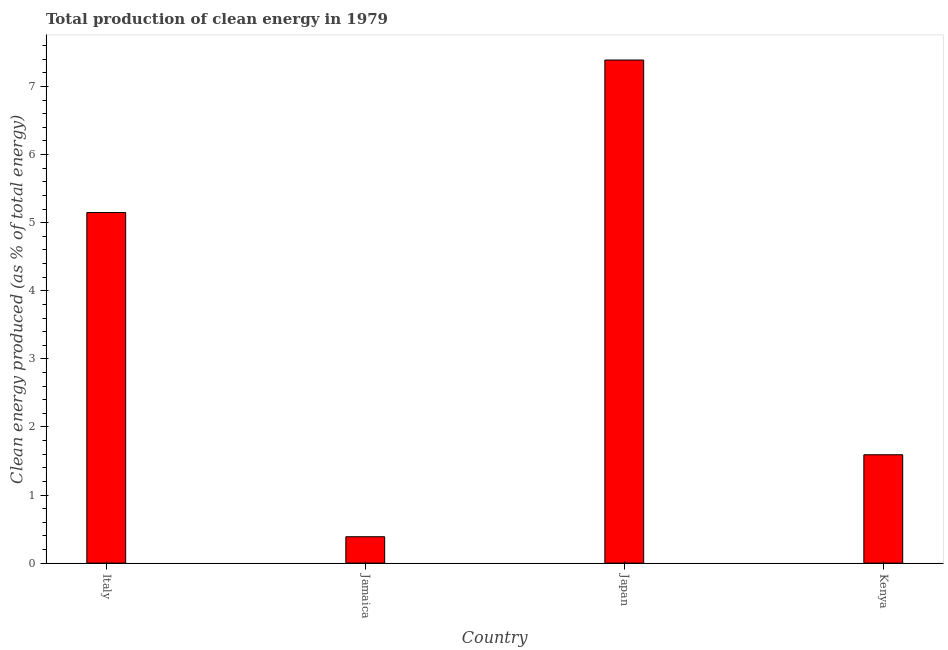Does the graph contain grids?
Make the answer very short. No. What is the title of the graph?
Make the answer very short. Total production of clean energy in 1979. What is the label or title of the X-axis?
Your response must be concise. Country. What is the label or title of the Y-axis?
Keep it short and to the point. Clean energy produced (as % of total energy). What is the production of clean energy in Japan?
Offer a very short reply. 7.39. Across all countries, what is the maximum production of clean energy?
Your response must be concise. 7.39. Across all countries, what is the minimum production of clean energy?
Offer a very short reply. 0.39. In which country was the production of clean energy maximum?
Your answer should be compact. Japan. In which country was the production of clean energy minimum?
Your answer should be compact. Jamaica. What is the sum of the production of clean energy?
Keep it short and to the point. 14.52. What is the difference between the production of clean energy in Italy and Jamaica?
Your response must be concise. 4.76. What is the average production of clean energy per country?
Provide a short and direct response. 3.63. What is the median production of clean energy?
Ensure brevity in your answer.  3.37. What is the ratio of the production of clean energy in Japan to that in Kenya?
Offer a very short reply. 4.64. Is the production of clean energy in Jamaica less than that in Japan?
Your answer should be compact. Yes. Is the difference between the production of clean energy in Italy and Kenya greater than the difference between any two countries?
Provide a succinct answer. No. What is the difference between the highest and the second highest production of clean energy?
Give a very brief answer. 2.24. In how many countries, is the production of clean energy greater than the average production of clean energy taken over all countries?
Your answer should be very brief. 2. Are all the bars in the graph horizontal?
Keep it short and to the point. No. How many countries are there in the graph?
Your answer should be compact. 4. Are the values on the major ticks of Y-axis written in scientific E-notation?
Keep it short and to the point. No. What is the Clean energy produced (as % of total energy) of Italy?
Give a very brief answer. 5.15. What is the Clean energy produced (as % of total energy) in Jamaica?
Your response must be concise. 0.39. What is the Clean energy produced (as % of total energy) of Japan?
Offer a very short reply. 7.39. What is the Clean energy produced (as % of total energy) in Kenya?
Ensure brevity in your answer.  1.59. What is the difference between the Clean energy produced (as % of total energy) in Italy and Jamaica?
Offer a very short reply. 4.76. What is the difference between the Clean energy produced (as % of total energy) in Italy and Japan?
Provide a succinct answer. -2.24. What is the difference between the Clean energy produced (as % of total energy) in Italy and Kenya?
Your response must be concise. 3.56. What is the difference between the Clean energy produced (as % of total energy) in Jamaica and Japan?
Ensure brevity in your answer.  -7. What is the difference between the Clean energy produced (as % of total energy) in Jamaica and Kenya?
Give a very brief answer. -1.2. What is the difference between the Clean energy produced (as % of total energy) in Japan and Kenya?
Provide a short and direct response. 5.8. What is the ratio of the Clean energy produced (as % of total energy) in Italy to that in Jamaica?
Offer a terse response. 13.3. What is the ratio of the Clean energy produced (as % of total energy) in Italy to that in Japan?
Your answer should be compact. 0.7. What is the ratio of the Clean energy produced (as % of total energy) in Italy to that in Kenya?
Provide a succinct answer. 3.24. What is the ratio of the Clean energy produced (as % of total energy) in Jamaica to that in Japan?
Offer a terse response. 0.05. What is the ratio of the Clean energy produced (as % of total energy) in Jamaica to that in Kenya?
Offer a terse response. 0.24. What is the ratio of the Clean energy produced (as % of total energy) in Japan to that in Kenya?
Your answer should be compact. 4.64. 